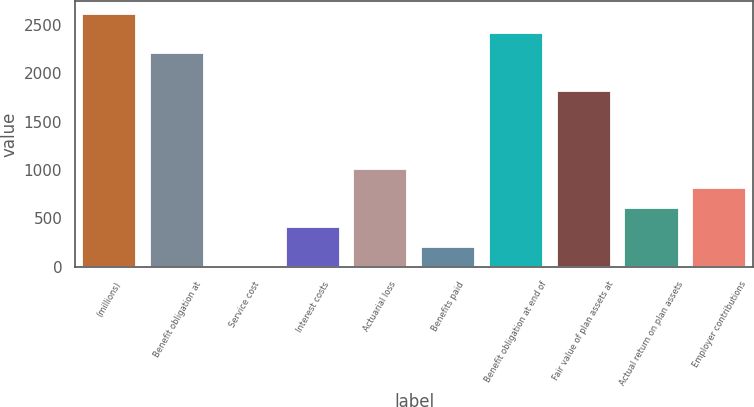<chart> <loc_0><loc_0><loc_500><loc_500><bar_chart><fcel>(millions)<fcel>Benefit obligation at<fcel>Service cost<fcel>Interest costs<fcel>Actuarial loss<fcel>Benefits paid<fcel>Benefit obligation at end of<fcel>Fair value of plan assets at<fcel>Actual return on plan assets<fcel>Employer contributions<nl><fcel>2613.56<fcel>2212.52<fcel>6.8<fcel>407.84<fcel>1009.4<fcel>207.32<fcel>2413.04<fcel>1811.48<fcel>608.36<fcel>808.88<nl></chart> 